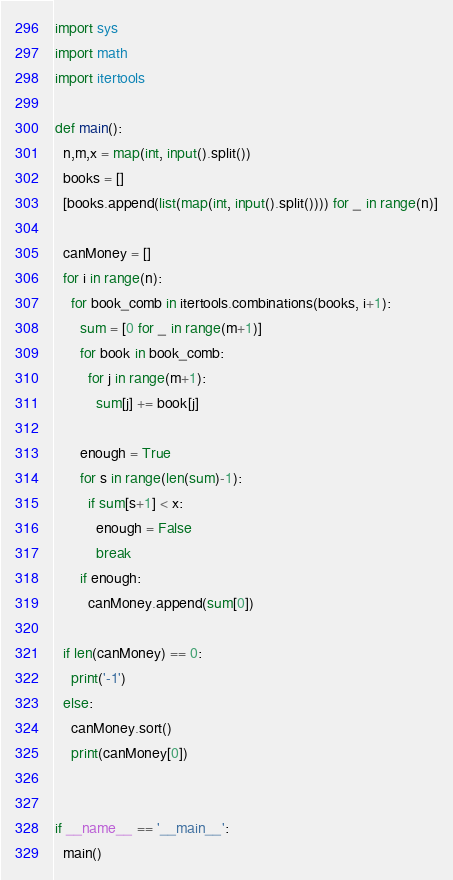Convert code to text. <code><loc_0><loc_0><loc_500><loc_500><_Python_>import sys
import math
import itertools

def main():
  n,m,x = map(int, input().split())
  books = []
  [books.append(list(map(int, input().split()))) for _ in range(n)]

  canMoney = []
  for i in range(n):
    for book_comb in itertools.combinations(books, i+1):
      sum = [0 for _ in range(m+1)]
      for book in book_comb:
        for j in range(m+1):
          sum[j] += book[j]
      
      enough = True
      for s in range(len(sum)-1):
        if sum[s+1] < x:
          enough = False
          break
      if enough:
        canMoney.append(sum[0])

  if len(canMoney) == 0:
    print('-1')
  else:
    canMoney.sort()
    print(canMoney[0])


if __name__ == '__main__':
  main()</code> 